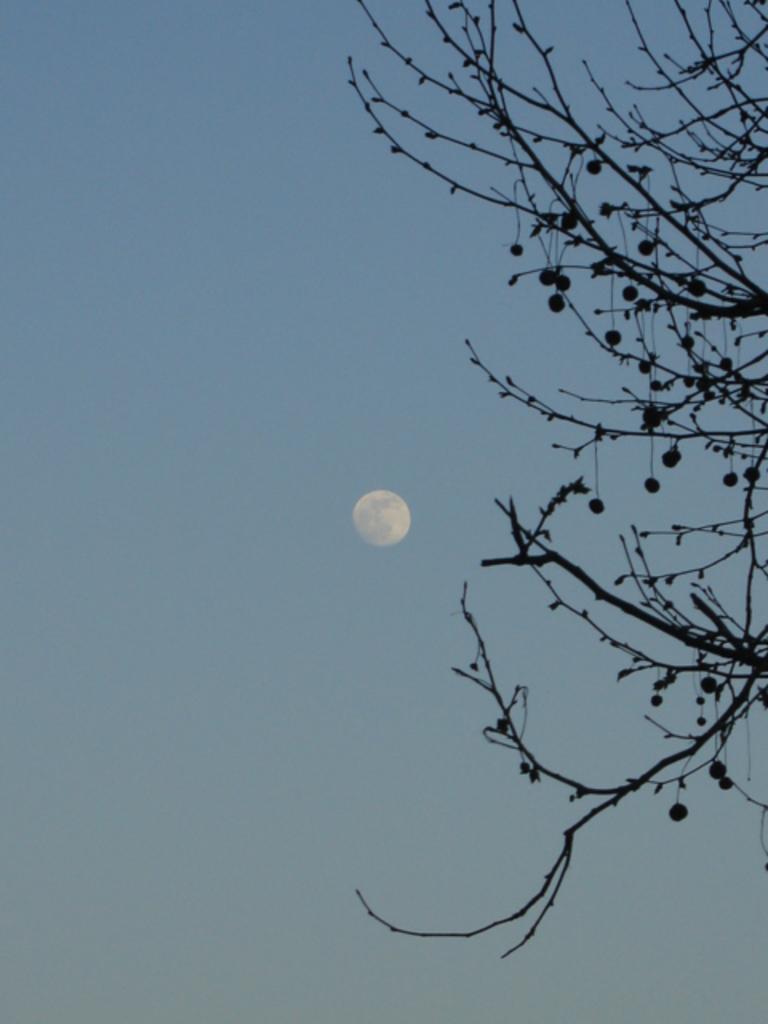How would you summarize this image in a sentence or two? This picture is clicked outside. On the right corner we can see the stems and branches of a tree and there are some objects hanging on the tree. In the background we can see the sky and there is a moon in the sky. 